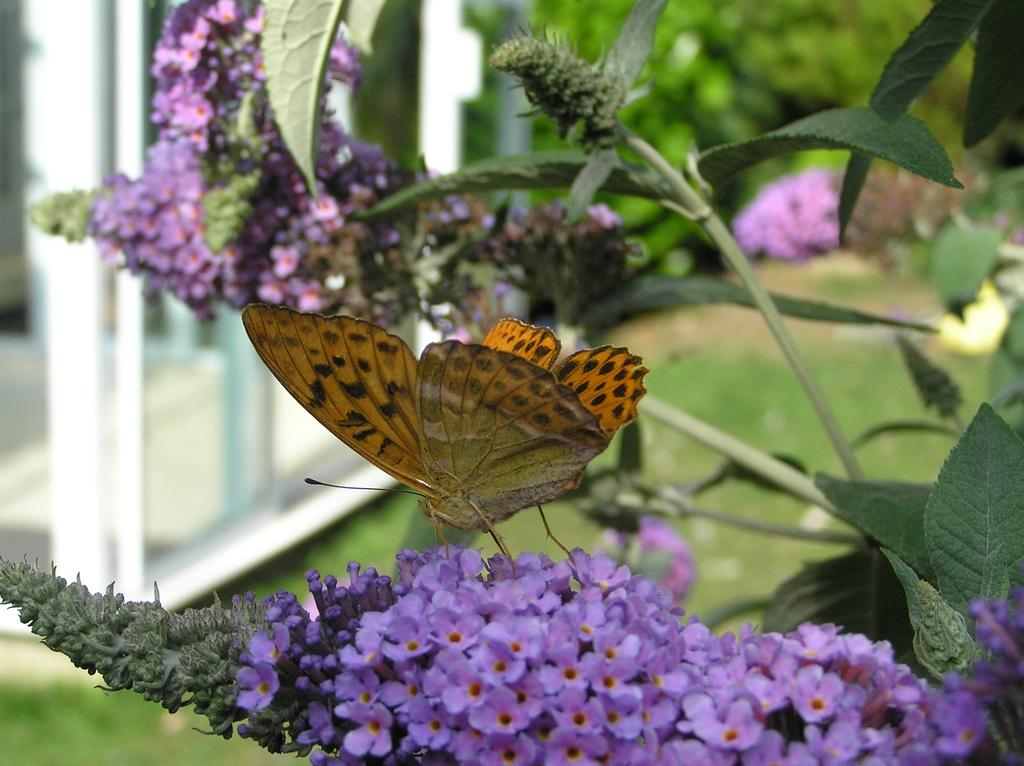What type of plants can be seen in the image? There are plants with flowers in the image. What other living organism is present in the image? There is a butterfly in the image. What type of ground cover is visible in the image? There is grass on the ground in the image. How would you describe the background of the image? The background of the image is blurred. What type of pest can be seen crawling on the canvas in the image? There is no canvas or pest present in the image. 